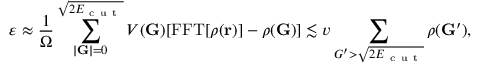Convert formula to latex. <formula><loc_0><loc_0><loc_500><loc_500>\varepsilon \approx \frac { 1 } { \Omega } \sum _ { | G | = 0 } ^ { \sqrt { 2 E _ { c u t } } } V ( G ) [ F F T [ \rho ( r ) ] - \rho ( G ) ] \lesssim v \sum _ { G ^ { \prime } > \sqrt { 2 E _ { c u t } } } \rho ( G ^ { \prime } ) ,</formula> 